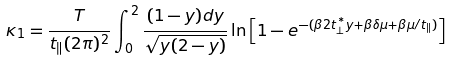Convert formula to latex. <formula><loc_0><loc_0><loc_500><loc_500>\kappa _ { 1 } = \frac { T } { t _ { \| } ( 2 \pi ) ^ { 2 } } \int _ { 0 } ^ { 2 } \frac { ( 1 - y ) d y } { \sqrt { y ( 2 - y ) } } \ln { \left [ 1 - e ^ { - ( \beta 2 t _ { \perp } ^ { \ast } y + \beta \delta \mu + \beta \mu / t _ { \| } ) } \right ] }</formula> 